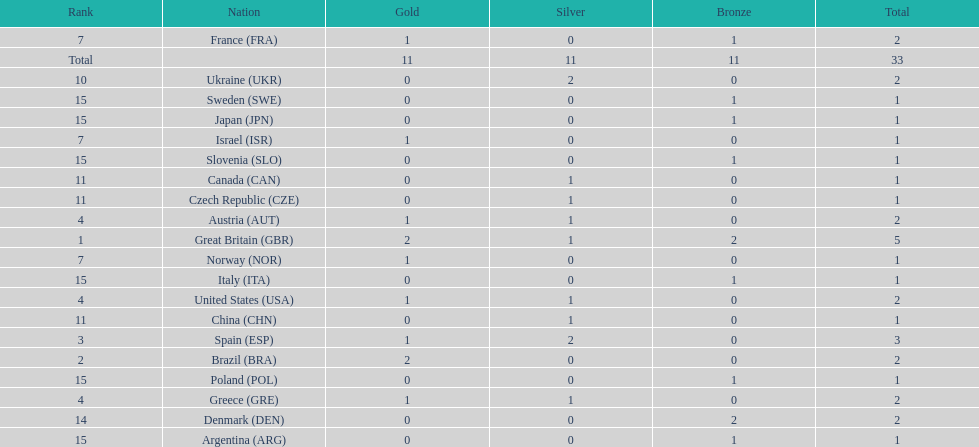Which country was adjacent to great britain in the overall medal tally? Spain. 